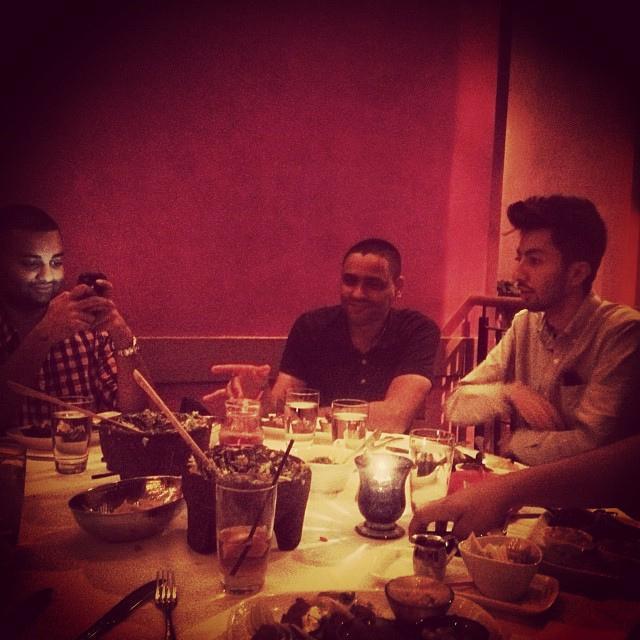How many lit candles on the table?
Give a very brief answer. 1. How many bowls are there?
Give a very brief answer. 5. How many people are there?
Give a very brief answer. 4. How many cups can be seen?
Give a very brief answer. 3. 